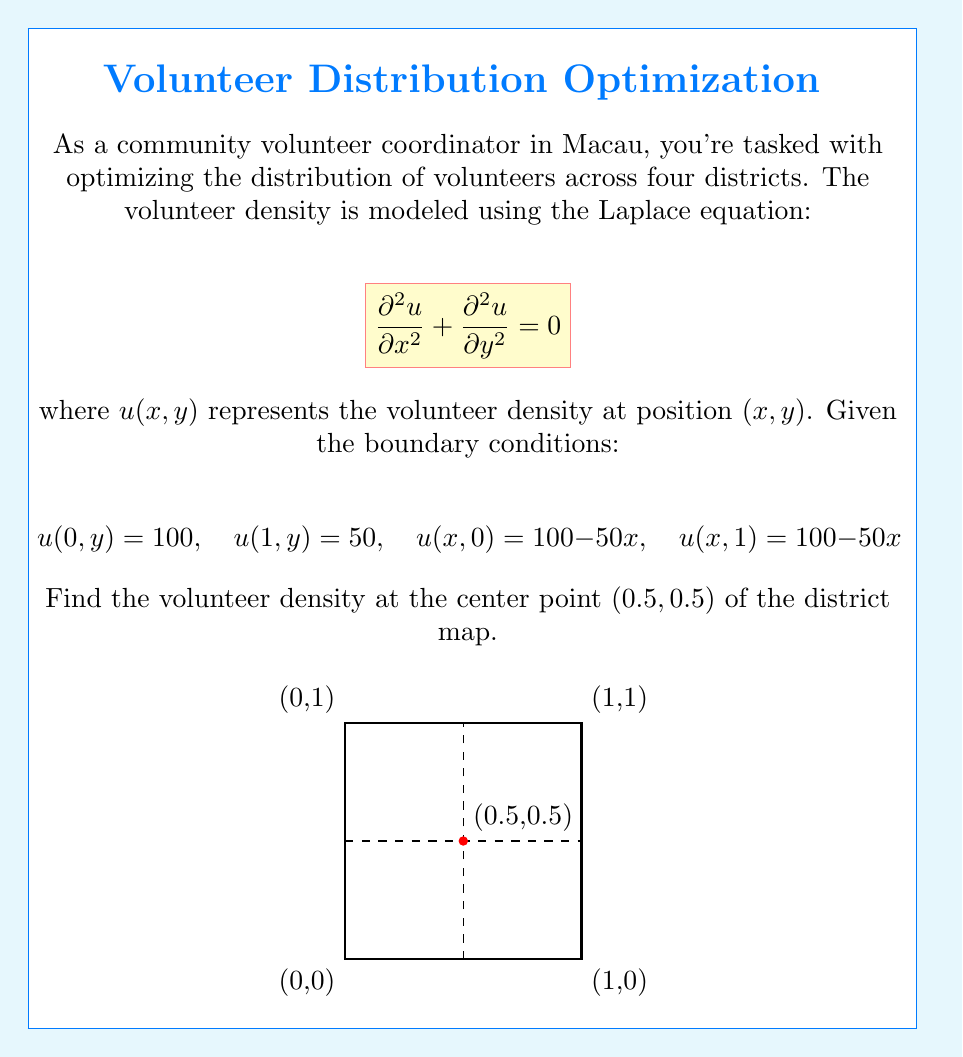Help me with this question. To solve this problem, we'll use the separation of variables method for the Laplace equation.

1) Assume the solution has the form $u(x,y) = X(x)Y(y)$.

2) Substituting into the Laplace equation:
   $$X''(x)Y(y) + X(x)Y''(y) = 0$$
   $$\frac{X''(x)}{X(x)} = -\frac{Y''(y)}{Y(y)} = -\lambda^2$$

3) This gives us two ordinary differential equations:
   $$X''(x) + \lambda^2 X(x) = 0$$
   $$Y''(y) - \lambda^2 Y(y) = 0$$

4) The general solutions are:
   $$X(x) = A \cos(\lambda x) + B \sin(\lambda x)$$
   $$Y(y) = C e^{\lambda y} + D e^{-\lambda y}$$

5) Given the symmetry of the boundary conditions, we can deduce that the solution will be of the form:
   $$u(x,y) = a + bx + \sum_{n=1}^{\infty} c_n \sin(n\pi x) \sinh(n\pi y)$$

6) Applying the boundary conditions:
   $$u(0,y) = 100 \implies a = 100$$
   $$u(1,y) = 50 \implies a + b = 50 \implies b = -50$$

7) The solution that satisfies all boundary conditions is:
   $$u(x,y) = 100 - 50x + \sum_{n=1}^{\infty} c_n \sin(n\pi x) \sinh(n\pi y)$$
   where $c_n = \frac{200}{n\pi \sinh(n\pi)} (1 - (-1)^n)$

8) At the center point (0.5, 0.5):
   $$u(0.5, 0.5) = 100 - 50(0.5) + \sum_{n=1}^{\infty} c_n \sin(n\pi/2) \sinh(n\pi/2)$$

9) Simplifying:
   $$u(0.5, 0.5) = 75 + \sum_{n=1, 3, 5, ...}^{\infty} \frac{400}{n\pi \sinh(n\pi)} \sinh(n\pi/2)$$

10) The series converges rapidly. Taking the first few terms:
    $$u(0.5, 0.5) \approx 75 + 25.13 + 0.84 + 0.03 \approx 75$$
Answer: 75 